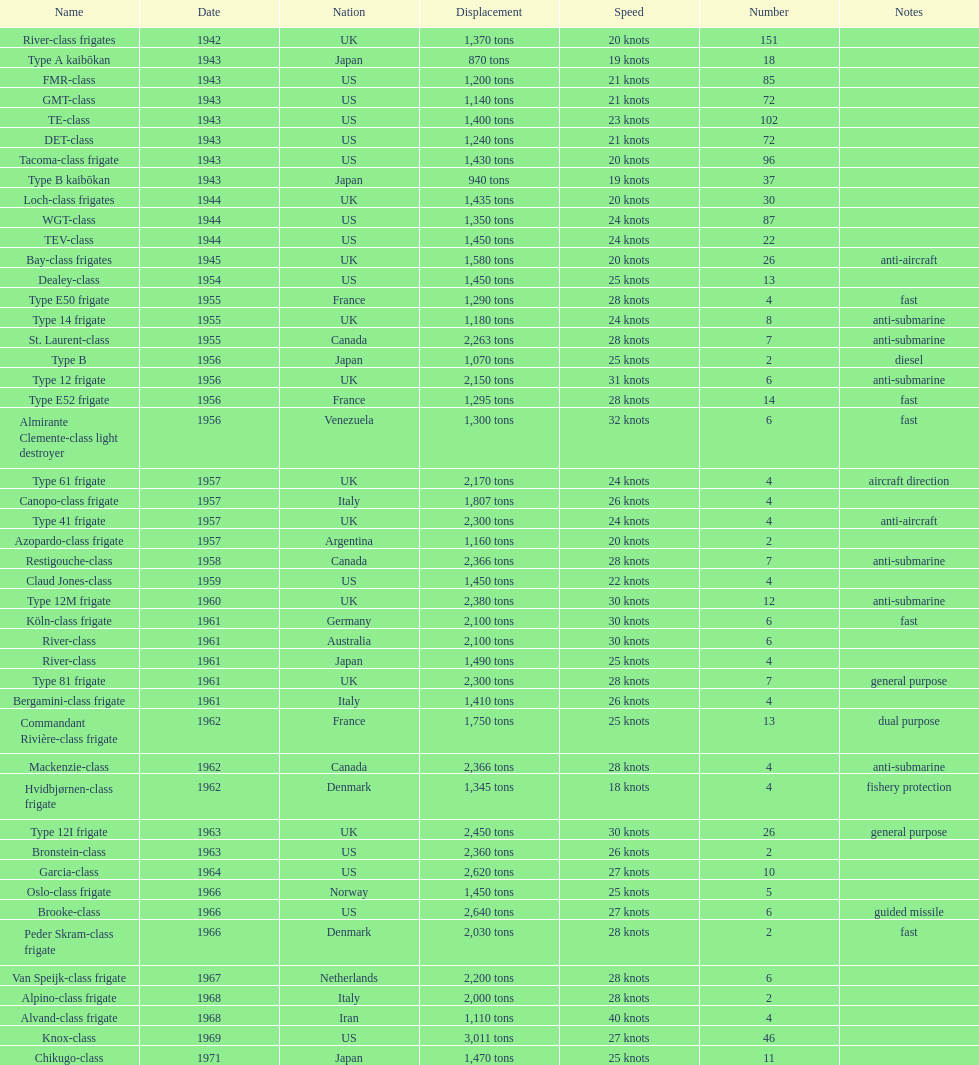How many tons of displacement are present in type b? 940 tons. 